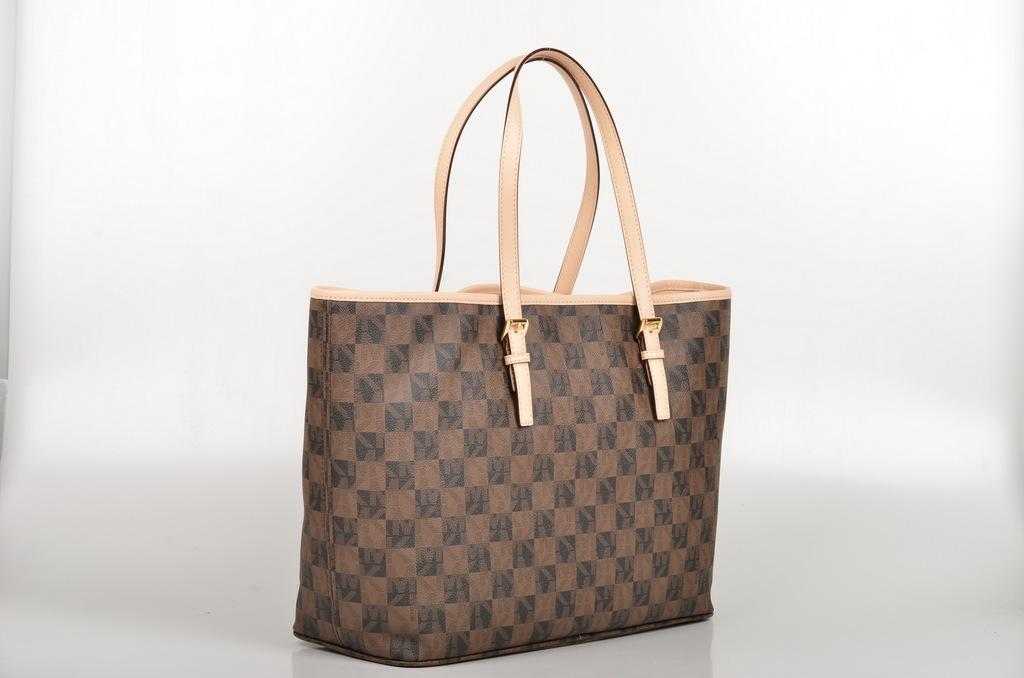What type of accessory is in the image? There is a handbag in the image. How many handles does the handbag have? The handbag has two handles. What colors can be seen on the handbag? The handbag is brown and black in color. Where is the handbag placed in the image? The handbag is placed on a white table. What is the color of the background in the image? The background of the image is white. Is there a spy observing the handbag in the image? There is no indication of a spy or any surveillance activity in the image; it simply shows a handbag placed on a white table. 